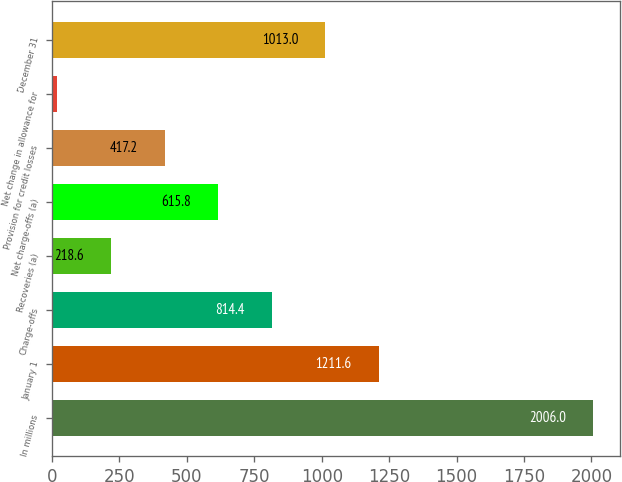Convert chart. <chart><loc_0><loc_0><loc_500><loc_500><bar_chart><fcel>In millions<fcel>January 1<fcel>Charge-offs<fcel>Recoveries (a)<fcel>Net charge-offs (a)<fcel>Provision for credit losses<fcel>Net change in allowance for<fcel>December 31<nl><fcel>2006<fcel>1211.6<fcel>814.4<fcel>218.6<fcel>615.8<fcel>417.2<fcel>20<fcel>1013<nl></chart> 